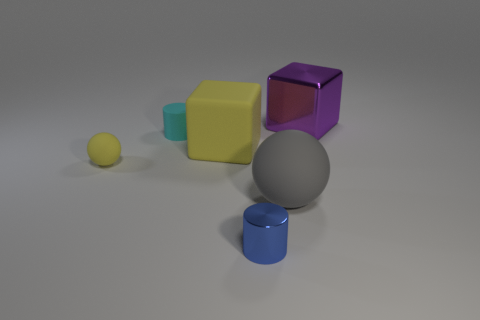Do the small sphere and the big matte cube have the same color? Yes, they both appear to share the same shade of grey. Grey can look different on various shapes due to lighting and shadows, but in this case, the color is consistent between the small sphere and the large matte cube. 